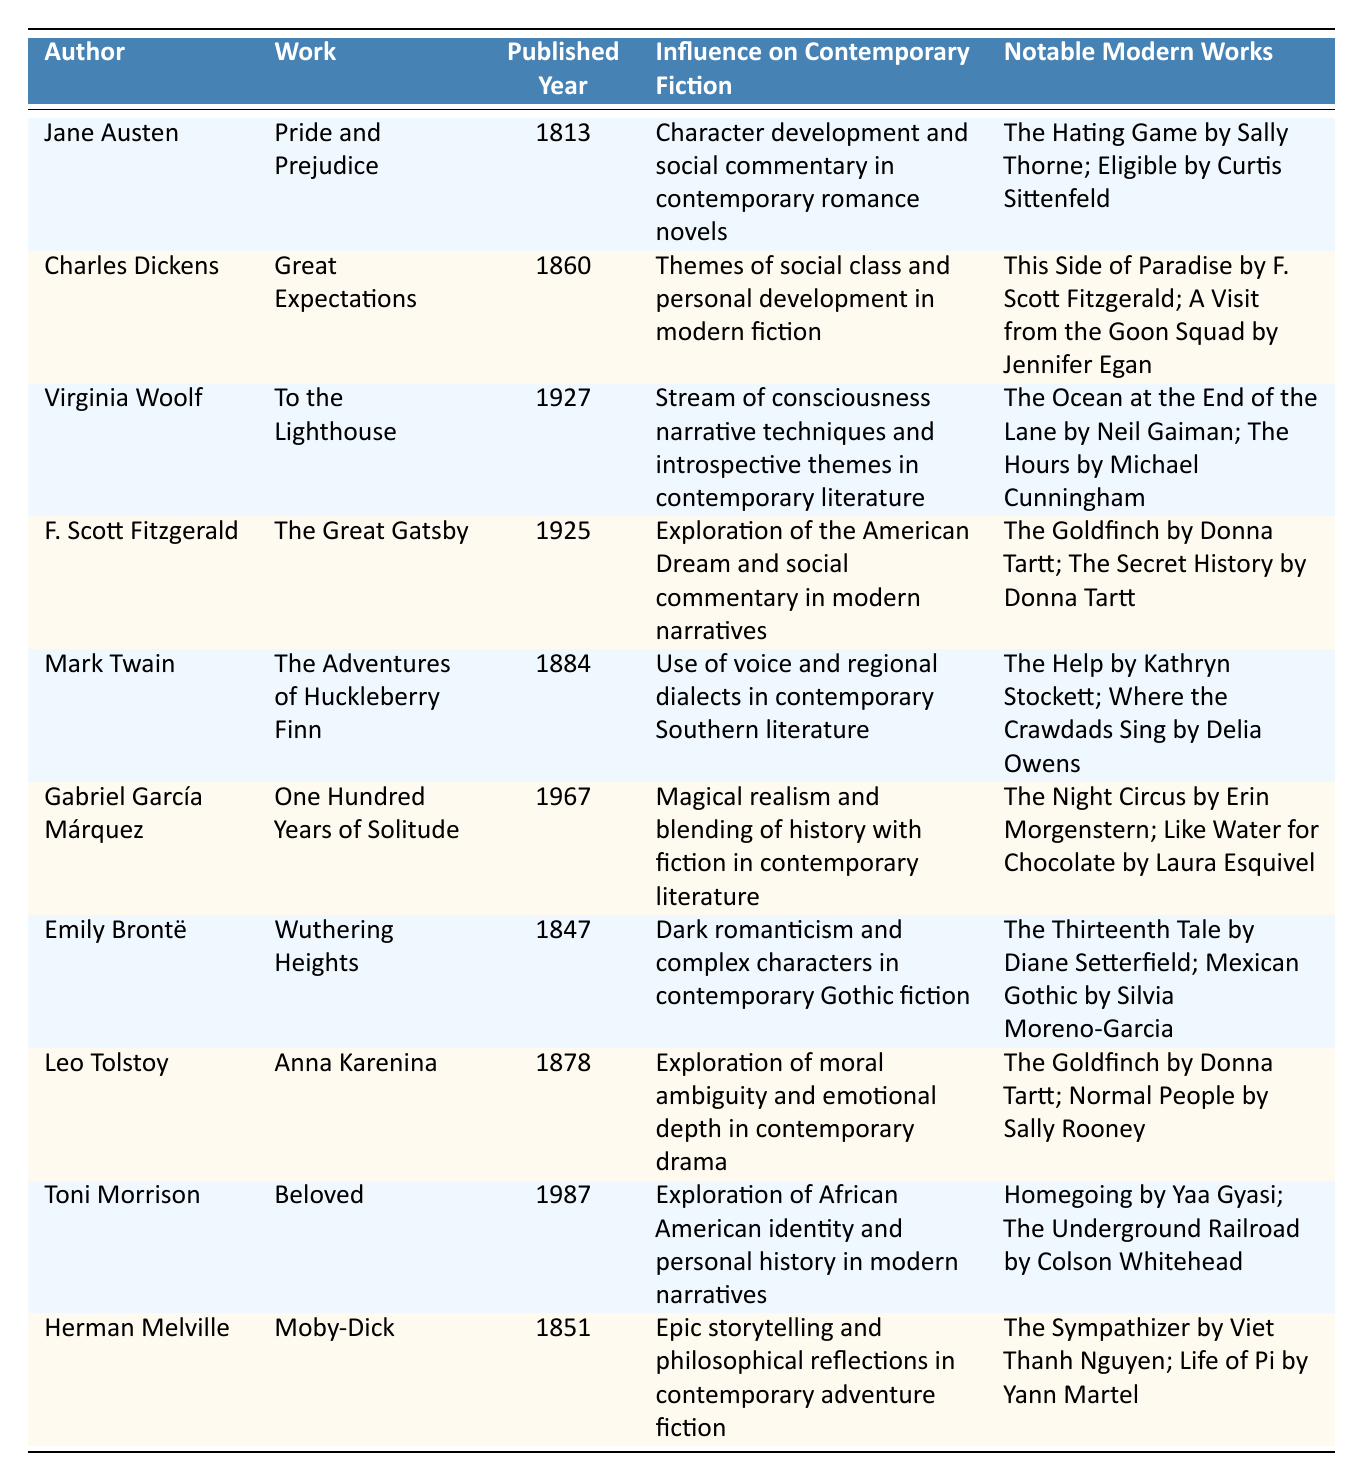What is the published year of "Pride and Prejudice"? The table shows that "Pride and Prejudice" by Jane Austen is published in 1813.
Answer: 1813 Which author influenced the themes of social class and personal development in modern fiction? The table indicates that Charles Dickens' work "Great Expectations" had an influence on themes of social class and personal development.
Answer: Charles Dickens Is "The Great Gatsby" associated with the exploration of the American Dream? According to the table, "The Great Gatsby" by F. Scott Fitzgerald is noted for its exploration of the American Dream and social commentary.
Answer: Yes Which notable modern work is associated with Virginia Woolf's influence? The table lists "The Ocean at the End of the Lane" by Neil Gaiman and "The Hours" by Michael Cunningham as notable modern works influenced by Virginia Woolf.
Answer: The Ocean at the End of the Lane; The Hours How many authors listed had their works published in the 19th century? The authors with works published in the 19th century are Jane Austen, Charles Dickens, Mark Twain, Emily Brontë, and Leo Tolstoy, making it a total of five authors.
Answer: 5 Which author is known for using magical realism in their writing? The table shows that Gabriel García Márquez is associated with the use of magical realism, specifically with his work "One Hundred Years of Solitude."
Answer: Gabriel García Márquez What is the connection between "Beloved" and contemporary literature? The table notes that Toni Morrison's "Beloved" explores African American identity and personal history, which influences modern narratives.
Answer: African American identity and personal history How many notable modern works are associated with F. Scott Fitzgerald's influence on contemporary fiction? Two notable modern works are linked to F. Scott Fitzgerald: "The Goldfinch" by Donna Tartt and "The Secret History" by Donna Tartt, totaling two works.
Answer: 2 Which two authors had their works published in the same year, and what were their works? The table does not show any authors with works published in the same year among those listed; thus, there are no pairs that have the same year.
Answer: None 